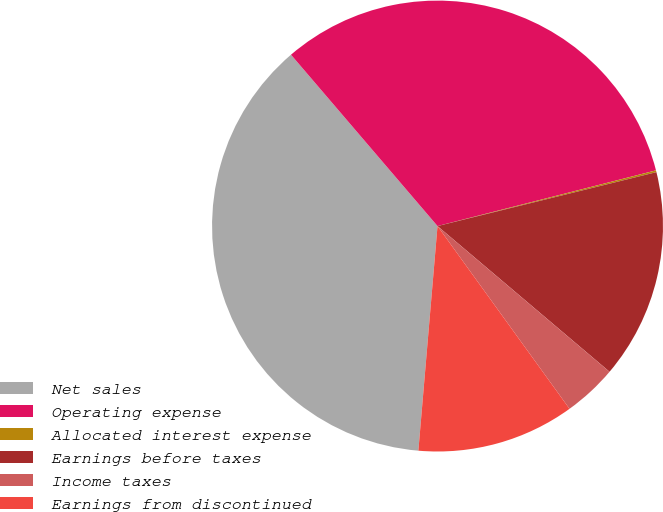Convert chart. <chart><loc_0><loc_0><loc_500><loc_500><pie_chart><fcel>Net sales<fcel>Operating expense<fcel>Allocated interest expense<fcel>Earnings before taxes<fcel>Income taxes<fcel>Earnings from discontinued<nl><fcel>37.39%<fcel>32.29%<fcel>0.13%<fcel>15.03%<fcel>3.86%<fcel>11.31%<nl></chart> 